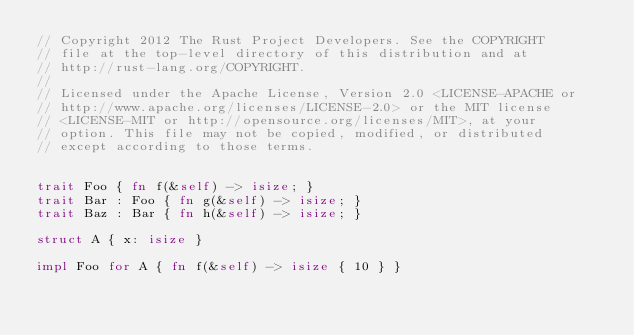Convert code to text. <code><loc_0><loc_0><loc_500><loc_500><_Rust_>// Copyright 2012 The Rust Project Developers. See the COPYRIGHT
// file at the top-level directory of this distribution and at
// http://rust-lang.org/COPYRIGHT.
//
// Licensed under the Apache License, Version 2.0 <LICENSE-APACHE or
// http://www.apache.org/licenses/LICENSE-2.0> or the MIT license
// <LICENSE-MIT or http://opensource.org/licenses/MIT>, at your
// option. This file may not be copied, modified, or distributed
// except according to those terms.


trait Foo { fn f(&self) -> isize; }
trait Bar : Foo { fn g(&self) -> isize; }
trait Baz : Bar { fn h(&self) -> isize; }

struct A { x: isize }

impl Foo for A { fn f(&self) -> isize { 10 } }</code> 